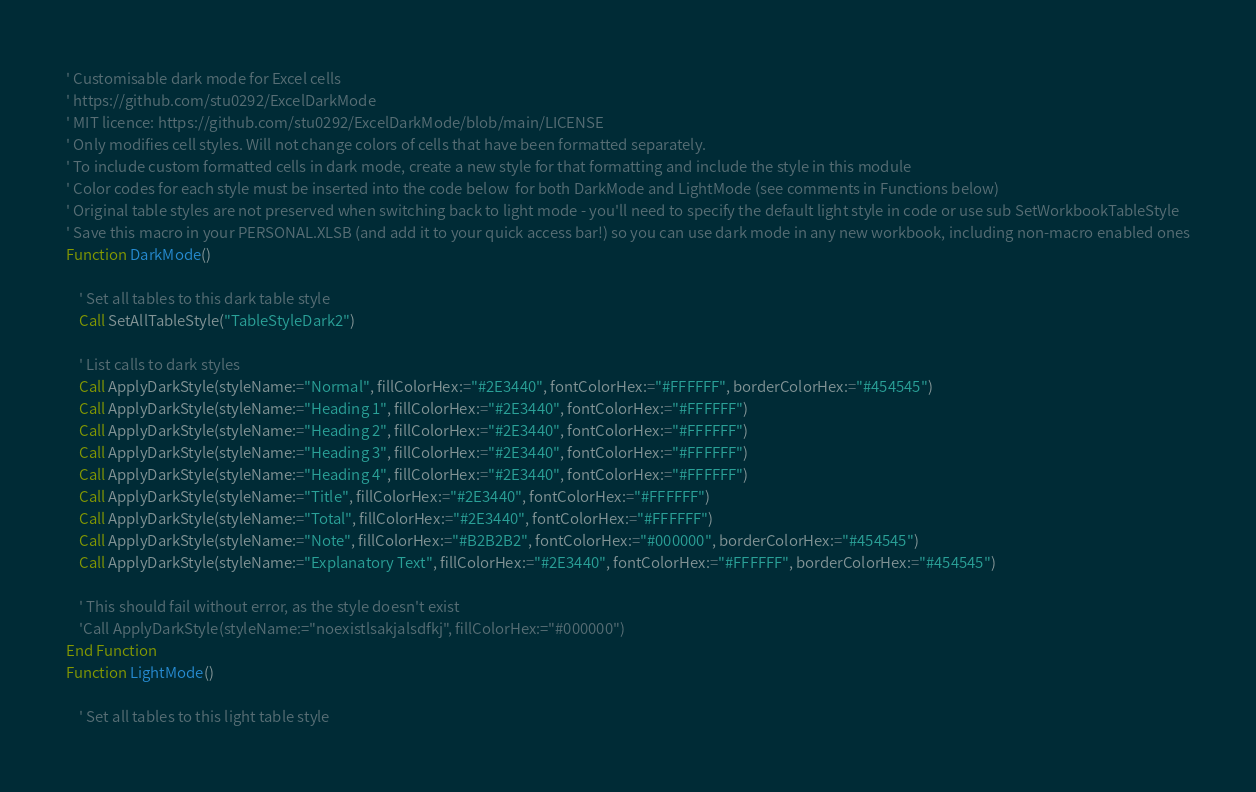<code> <loc_0><loc_0><loc_500><loc_500><_VisualBasic_>' Customisable dark mode for Excel cells
' https://github.com/stu0292/ExcelDarkMode
' MIT licence: https://github.com/stu0292/ExcelDarkMode/blob/main/LICENSE
' Only modifies cell styles. Will not change colors of cells that have been formatted separately.
' To include custom formatted cells in dark mode, create a new style for that formatting and include the style in this module
' Color codes for each style must be inserted into the code below  for both DarkMode and LightMode (see comments in Functions below)
' Original table styles are not preserved when switching back to light mode - you'll need to specify the default light style in code or use sub SetWorkbookTableStyle
' Save this macro in your PERSONAL.XLSB (and add it to your quick access bar!) so you can use dark mode in any new workbook, including non-macro enabled ones
Function DarkMode()
    
    ' Set all tables to this dark table style
    Call SetAllTableStyle("TableStyleDark2")

    ' List calls to dark styles
    Call ApplyDarkStyle(styleName:="Normal", fillColorHex:="#2E3440", fontColorHex:="#FFFFFF", borderColorHex:="#454545")
    Call ApplyDarkStyle(styleName:="Heading 1", fillColorHex:="#2E3440", fontColorHex:="#FFFFFF")
    Call ApplyDarkStyle(styleName:="Heading 2", fillColorHex:="#2E3440", fontColorHex:="#FFFFFF")
    Call ApplyDarkStyle(styleName:="Heading 3", fillColorHex:="#2E3440", fontColorHex:="#FFFFFF")
    Call ApplyDarkStyle(styleName:="Heading 4", fillColorHex:="#2E3440", fontColorHex:="#FFFFFF")
    Call ApplyDarkStyle(styleName:="Title", fillColorHex:="#2E3440", fontColorHex:="#FFFFFF")
    Call ApplyDarkStyle(styleName:="Total", fillColorHex:="#2E3440", fontColorHex:="#FFFFFF")
    Call ApplyDarkStyle(styleName:="Note", fillColorHex:="#B2B2B2", fontColorHex:="#000000", borderColorHex:="#454545")
    Call ApplyDarkStyle(styleName:="Explanatory Text", fillColorHex:="#2E3440", fontColorHex:="#FFFFFF", borderColorHex:="#454545")
    
    ' This should fail without error, as the style doesn't exist
    'Call ApplyDarkStyle(styleName:="noexistlsakjalsdfkj", fillColorHex:="#000000")
End Function
Function LightMode()
    
    ' Set all tables to this light table style</code> 